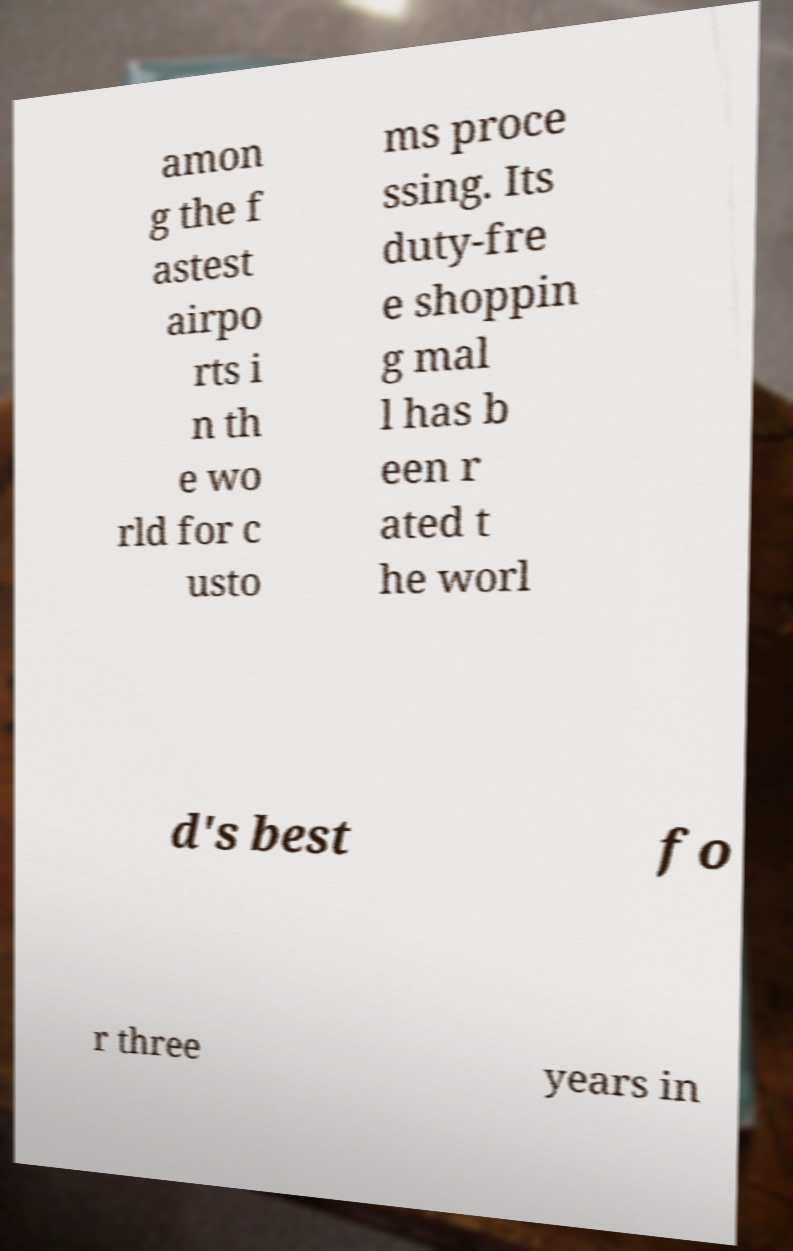Could you extract and type out the text from this image? amon g the f astest airpo rts i n th e wo rld for c usto ms proce ssing. Its duty-fre e shoppin g mal l has b een r ated t he worl d's best fo r three years in 